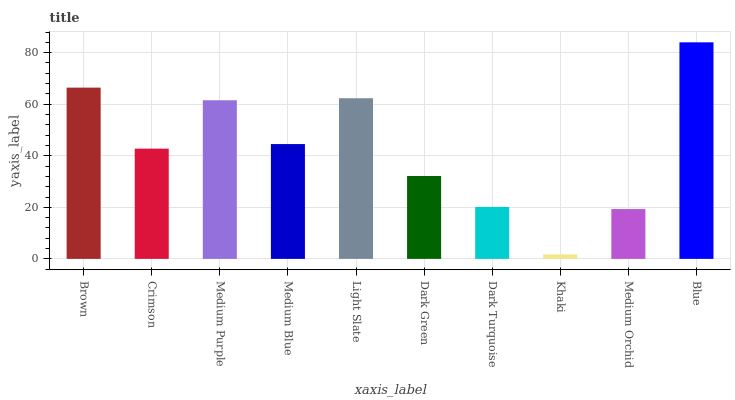Is Khaki the minimum?
Answer yes or no. Yes. Is Blue the maximum?
Answer yes or no. Yes. Is Crimson the minimum?
Answer yes or no. No. Is Crimson the maximum?
Answer yes or no. No. Is Brown greater than Crimson?
Answer yes or no. Yes. Is Crimson less than Brown?
Answer yes or no. Yes. Is Crimson greater than Brown?
Answer yes or no. No. Is Brown less than Crimson?
Answer yes or no. No. Is Medium Blue the high median?
Answer yes or no. Yes. Is Crimson the low median?
Answer yes or no. Yes. Is Blue the high median?
Answer yes or no. No. Is Blue the low median?
Answer yes or no. No. 